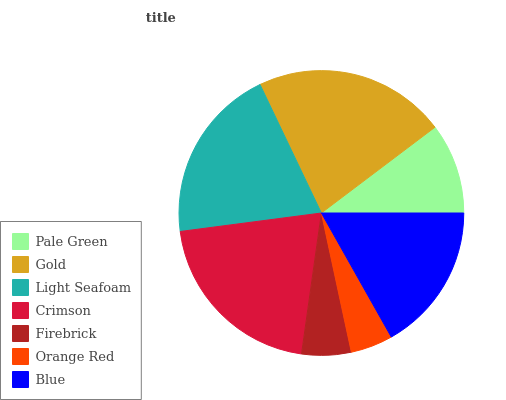Is Orange Red the minimum?
Answer yes or no. Yes. Is Gold the maximum?
Answer yes or no. Yes. Is Light Seafoam the minimum?
Answer yes or no. No. Is Light Seafoam the maximum?
Answer yes or no. No. Is Gold greater than Light Seafoam?
Answer yes or no. Yes. Is Light Seafoam less than Gold?
Answer yes or no. Yes. Is Light Seafoam greater than Gold?
Answer yes or no. No. Is Gold less than Light Seafoam?
Answer yes or no. No. Is Blue the high median?
Answer yes or no. Yes. Is Blue the low median?
Answer yes or no. Yes. Is Firebrick the high median?
Answer yes or no. No. Is Light Seafoam the low median?
Answer yes or no. No. 